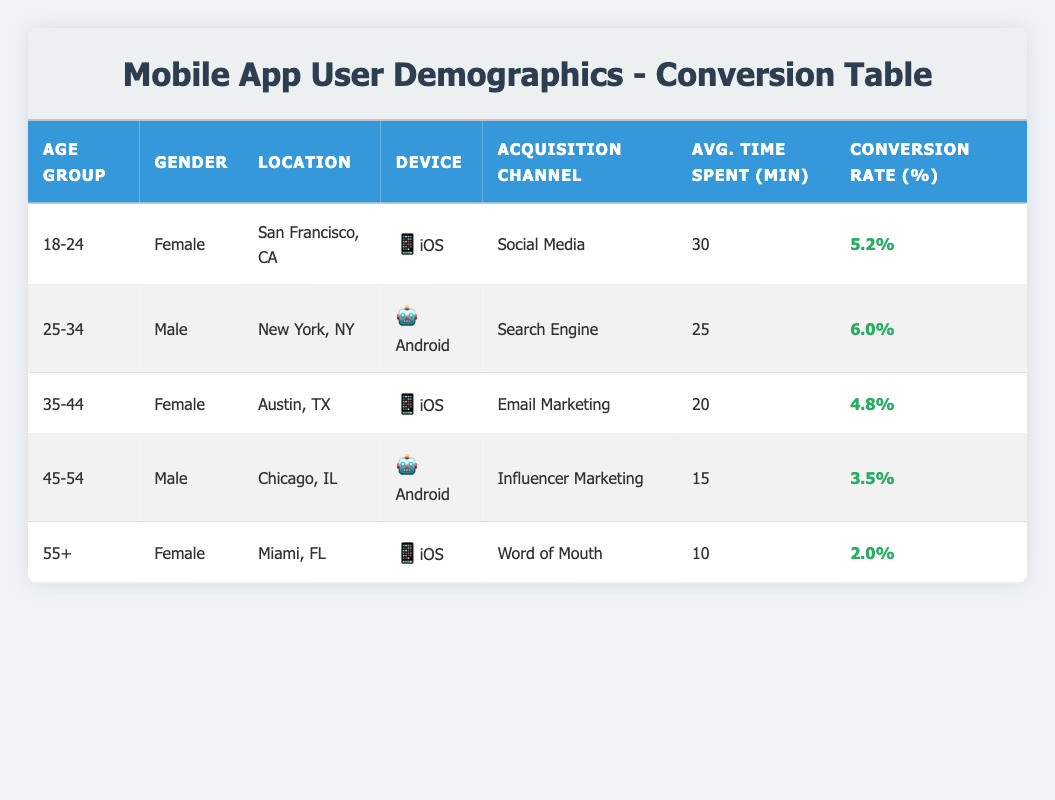What is the average conversion rate for the age group 18-24? The conversion rate for the age group 18-24 is 5.2% based on the table.
Answer: 5.2% What is the average time spent by male users? The male users are from two age groups: 25-34 (25 minutes) and 45-54 (15 minutes). The average time spent is (25 + 15) / 2 = 20 minutes.
Answer: 20 minutes Which demographic has the highest conversion rate? The highest conversion rate in the table is 6.0%, which is for male users aged 25-34.
Answer: 6.0% Is the average time spent by users aged 35-44 greater than that of users aged 45-54? Users aged 35-44 spend an average of 20 minutes, while those aged 45-54 spend 15 minutes. Since 20 is greater than 15, the statement is true.
Answer: Yes What is the total conversion rate for all age groups combined? The conversion rates are: 5.2%, 6.0%, 4.8%, 3.5%, and 2.0%. Adding these gives a total of 21.5%.
Answer: 21.5% How many female users are in the table? There are three female users in the age groups 18-24, 35-44, and 55+.
Answer: 3 What is the conversion rate for users who came from "Word of Mouth" as an acquisition channel? The conversion rate for the age group 55+ who came from "Word of Mouth" is 2.0%.
Answer: 2.0% Which location corresponds to the demographic with the lowest average time spent? The lowest average time spent is 10 minutes, which corresponds to female users located in Miami, FL.
Answer: Miami, FL What is the difference in conversion rates between the highest and lowest conversion rates? The highest conversion rate is 6.0%, and the lowest is 2.0%. The difference is 6.0 - 2.0 = 4.0%.
Answer: 4.0% 